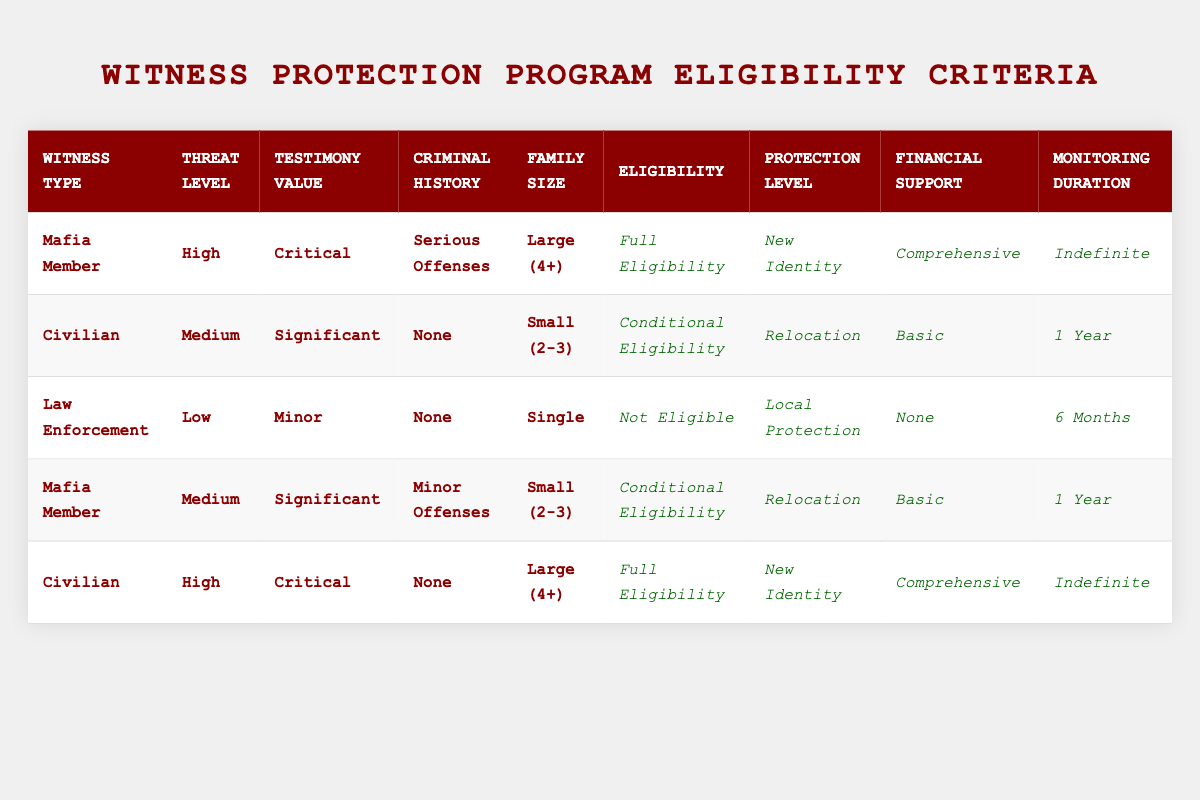What is the eligibility status for a Mafia member with serious offenses and a large family size? According to the table, a Mafia member with serious offenses and a large family size has "Full Eligibility." This is found in the first row of the table, which specifies these conditions.
Answer: Full Eligibility How many rows indicate Conditional Eligibility? To find out how many rows indicate Conditional Eligibility, we count the instances of this status in the Eligibility column. There are two entries marked "Conditional Eligibility" in the second and fourth rows.
Answer: 2 Is a civilian with minor criminal history eligible for the witness protection program? According to the table, civilians with "None" as their criminal history make up two entries. There are no entries for civilians with "Minor Offenses," so the answer is no based on the table data.
Answer: No What protection level is assigned to a civilian with high threat level and critical testimony value? Looking at the table, the civilian with a high threat level and critical testimony value, listed in the fifth row, receives "New Identity" as the protection level.
Answer: New Identity What is the monitoring duration for law enforcement members who are not eligible for protection? The table states that law enforcement members classified as "Not Eligible" have a monitoring duration of "6 Months," as indicated in the third row.
Answer: 6 Months How many different financial support levels are available for eligible witnesses according to the table? By analyzing the Financial Support column, the options listed are "None," "Basic," and "Comprehensive," totaling three distinct levels available for eligible witnesses.
Answer: 3 Is there a combination of witness type where someone has conditional eligibility and receives local protection? The configurations for "Conditional Eligibility" in rows two and four grant "Relocation" and "Relocation," respectively, and do not indicate "Local Protection." Therefore, there is no such combination based on the table data.
Answer: No What is the maximum threat level for which a civilian can achieve full eligibility? The table indicates that civilians with high threat levels receive "Full Eligibility," as seen in the last row. Thus, the maximum threat level for full eligibility for a civilian is "High."
Answer: High What is the common monitoring duration for both Mafia members with serious offenses and civilians with significant testimony value? Both Mafia members with serious offenses and civilians with significant testimony value have different monitoring durations. The Mafia member has "Indefinite," while the civilian has "1 Year." This shows they do not share a common monitoring duration, since they differ.
Answer: No common monitoring duration 